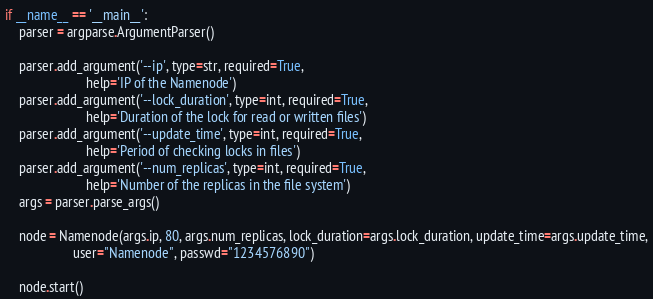Convert code to text. <code><loc_0><loc_0><loc_500><loc_500><_Python_>if __name__ == '__main__':
    parser = argparse.ArgumentParser()

    parser.add_argument('--ip', type=str, required=True,
                        help='IP of the Namenode')
    parser.add_argument('--lock_duration', type=int, required=True,
                        help='Duration of the lock for read or written files')
    parser.add_argument('--update_time', type=int, required=True,
                        help='Period of checking locks in files')
    parser.add_argument('--num_replicas', type=int, required=True,
                        help='Number of the replicas in the file system')
    args = parser.parse_args()

    node = Namenode(args.ip, 80, args.num_replicas, lock_duration=args.lock_duration, update_time=args.update_time,
                    user="Namenode", passwd="1234576890")

    node.start()
</code> 